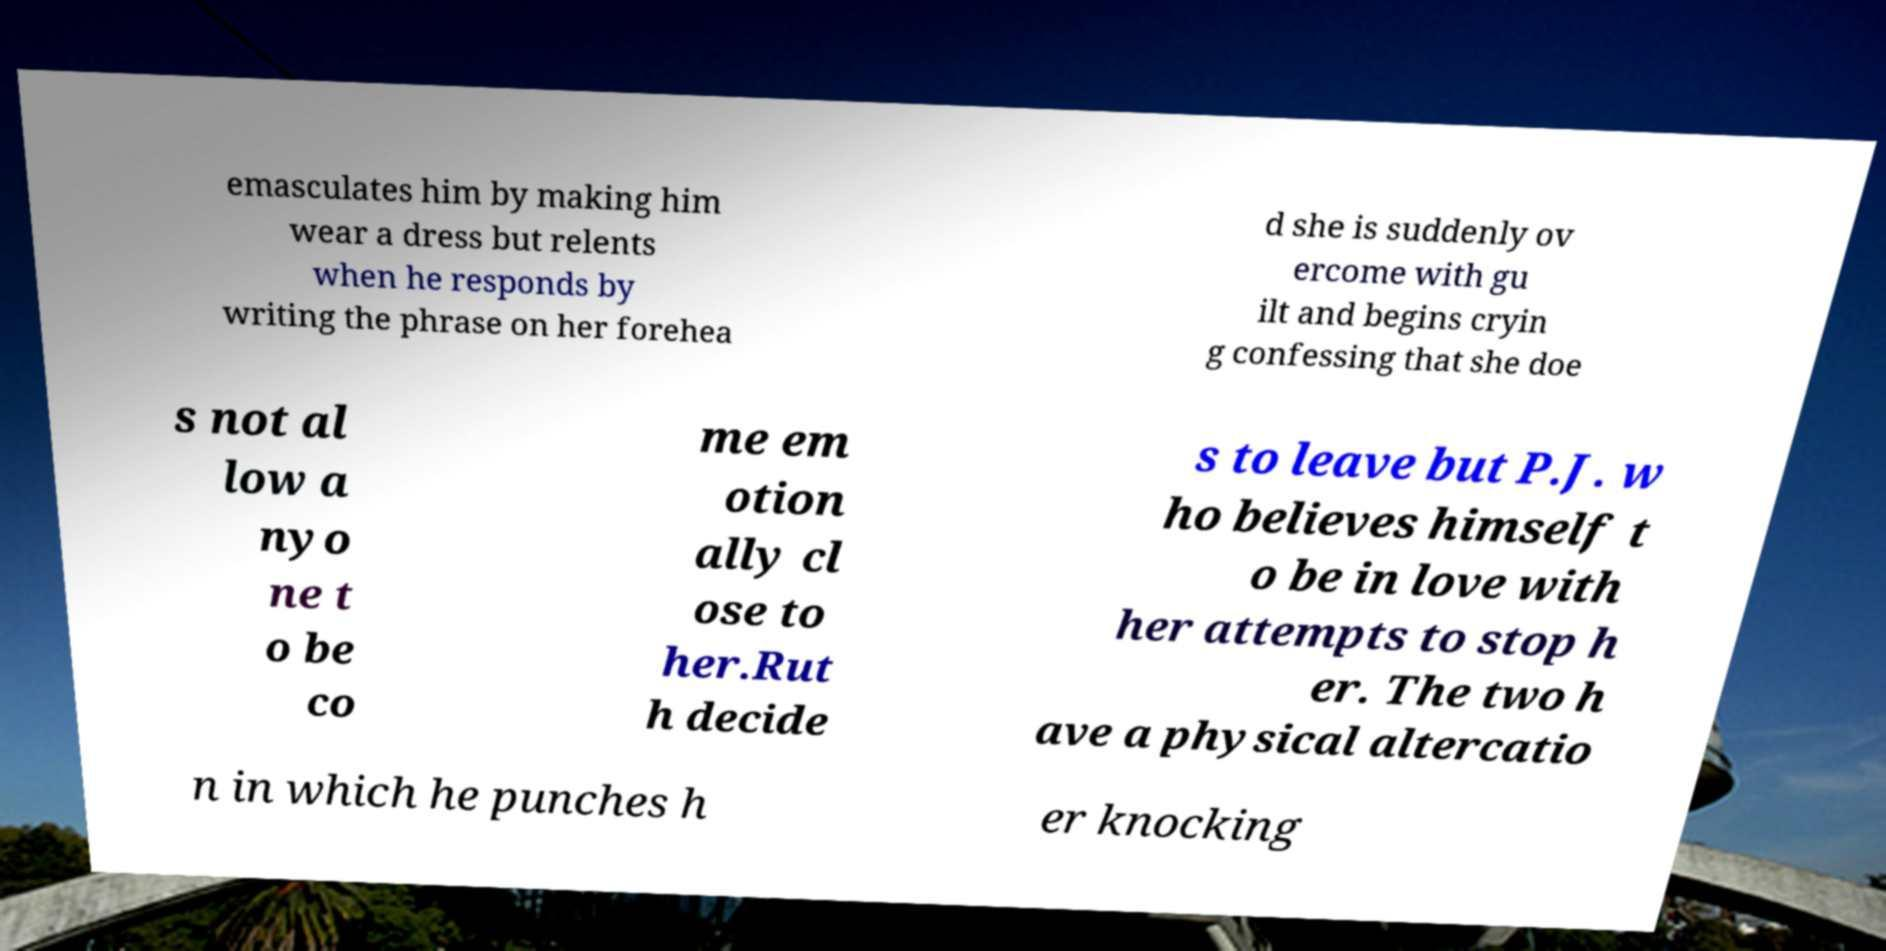Can you read and provide the text displayed in the image?This photo seems to have some interesting text. Can you extract and type it out for me? emasculates him by making him wear a dress but relents when he responds by writing the phrase on her forehea d she is suddenly ov ercome with gu ilt and begins cryin g confessing that she doe s not al low a nyo ne t o be co me em otion ally cl ose to her.Rut h decide s to leave but P.J. w ho believes himself t o be in love with her attempts to stop h er. The two h ave a physical altercatio n in which he punches h er knocking 